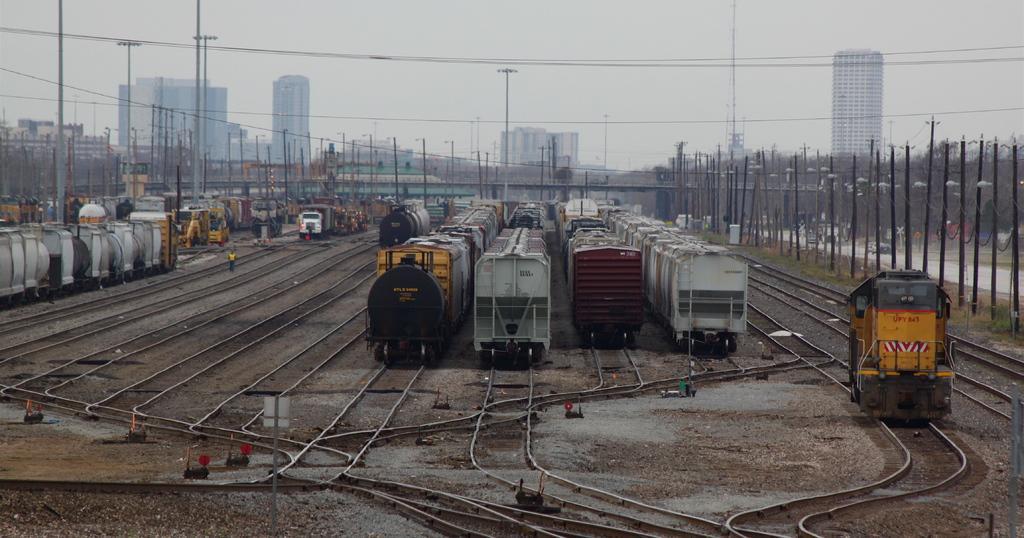In one or two sentences, can you explain what this image depicts? In the image there are many trains. At the bottom of the image there are many train tracks. And there are many poles with wires and lights. In the background there are buildings. At the top of the image there is sky. 